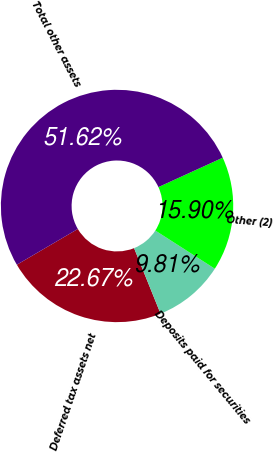Convert chart. <chart><loc_0><loc_0><loc_500><loc_500><pie_chart><fcel>Deferred tax assets net<fcel>Deposits paid for securities<fcel>Other (2)<fcel>Total other assets<nl><fcel>22.67%<fcel>9.81%<fcel>15.9%<fcel>51.62%<nl></chart> 